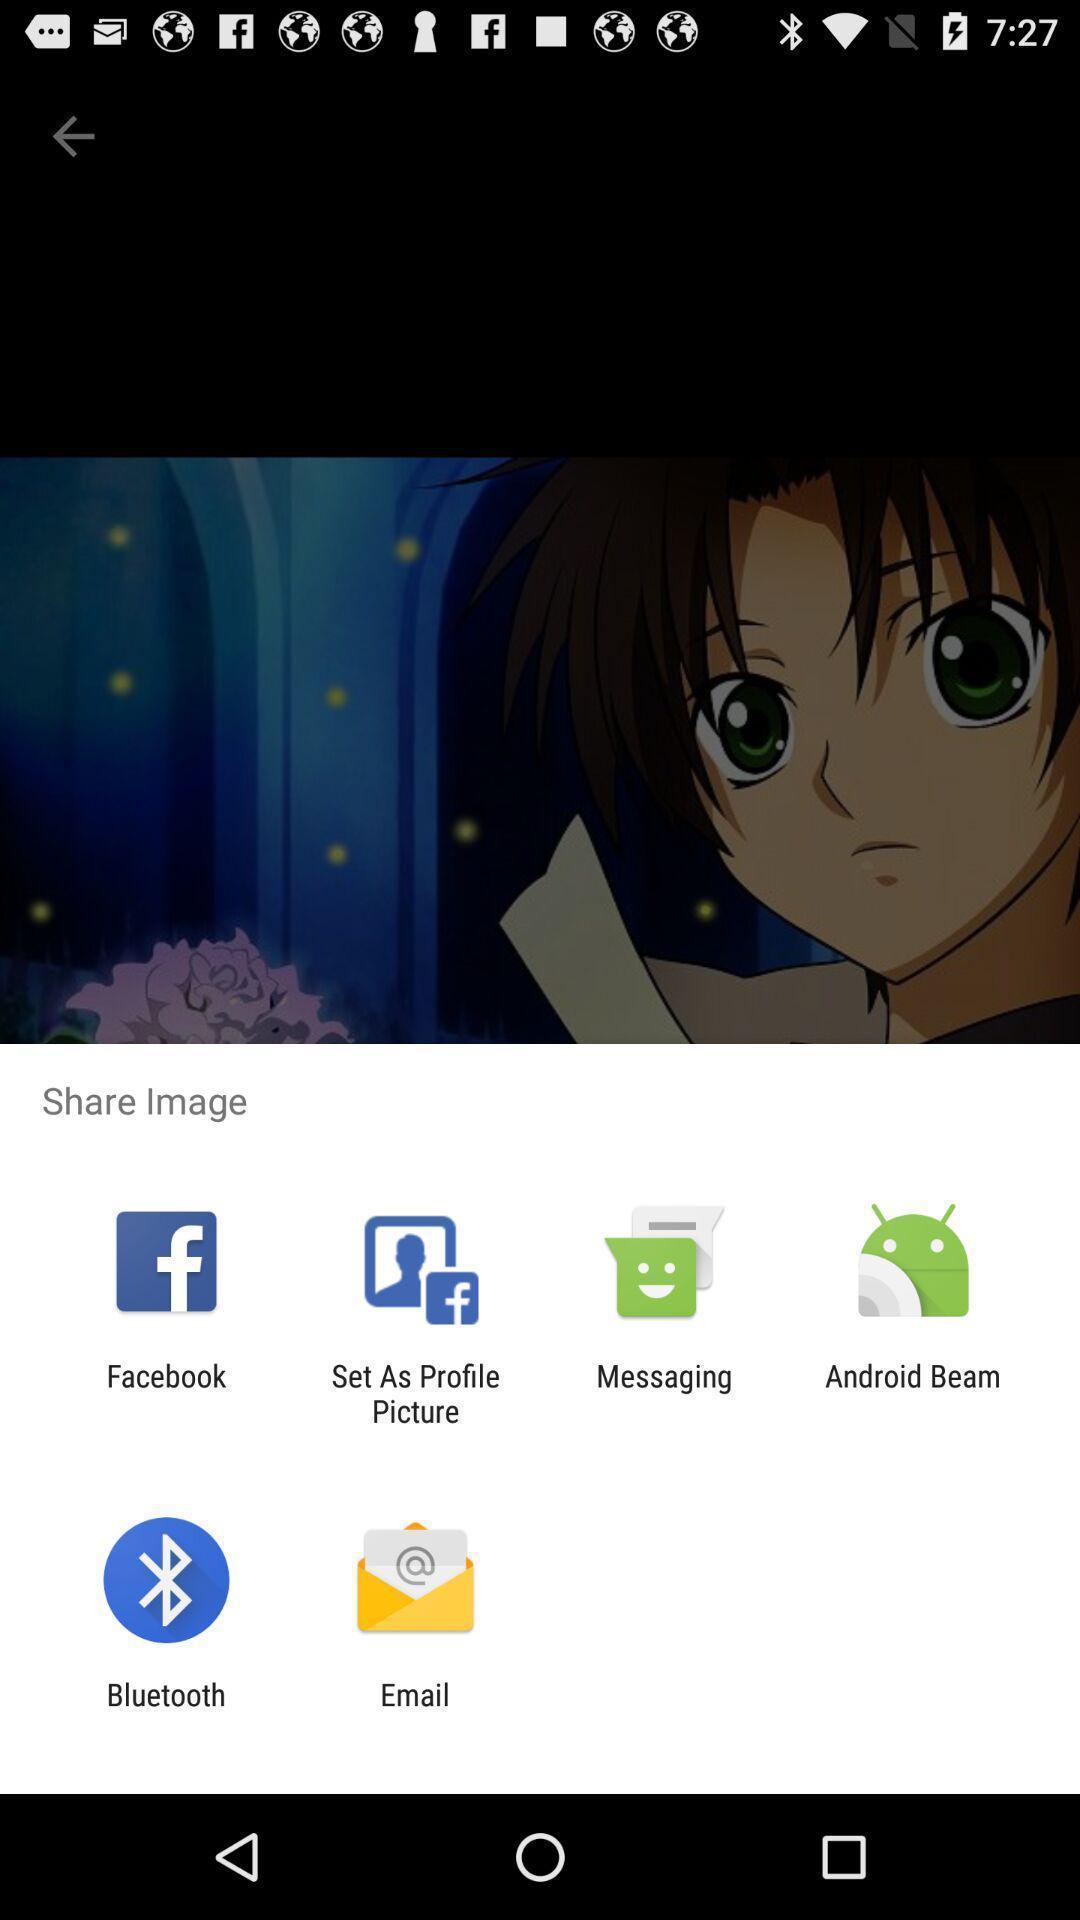Give me a narrative description of this picture. Pop-up showing different sharing options. 